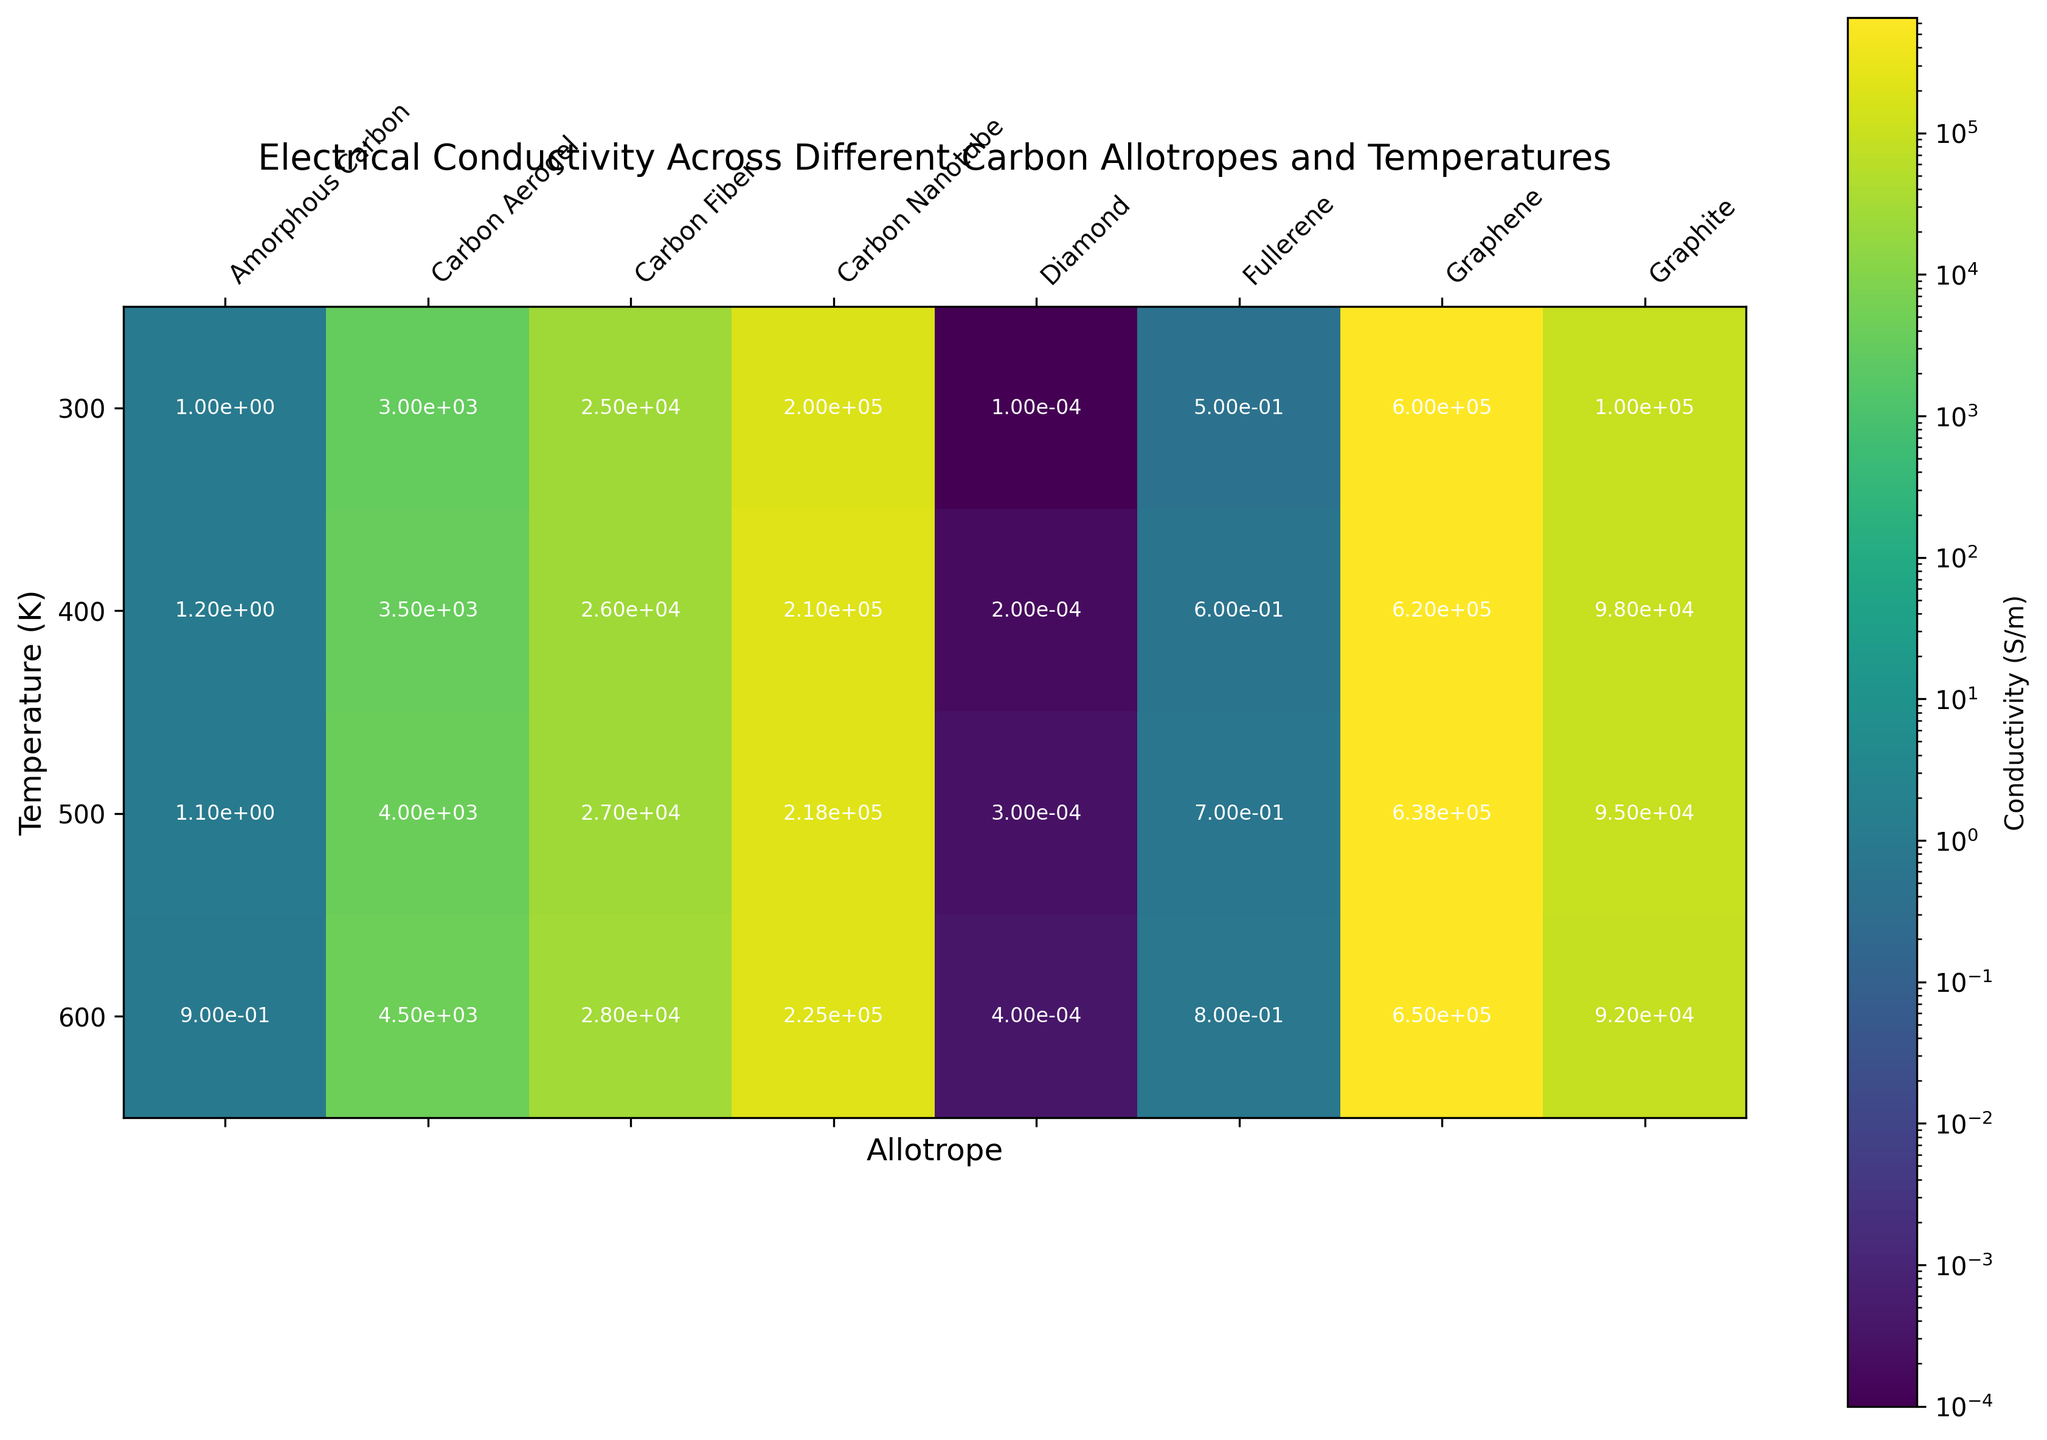Which carbon allotrope has the highest conductivity at 300 K? By observing the top row (300 K) of the heatmap, we need to identify the cell with the brightest color, indicating the highest conductivity. Graphene stands out with the brightest color and highest conductivity value.
Answer: Graphene How does the conductivity of carbon nanotube change from 300 K to 600 K? Locate the row corresponding to carbon nanotube in the heatmap. Note the conductivity values: 200,000 S/m at 300 K and 225,000 S/m at 600 K. Calculate the difference: 225,000 - 200,000 = 25,000 S/m. Thus, conductivity increases by 25,000 S/m.
Answer: Increases by 25,000 S/m Which allotrope shows the least change in conductivity across the temperature range? Examine the color variations for each column from 300 K to 600 K. The column with the least noticeable change is for amorphous carbon, showing stable or minimal changes in color shades.
Answer: Amorphous Carbon What is the ratio of graphene's conductivity to graphite's conductivity at 500 K? Find the conductivities for both materials at 500 K: Graphene is 638,000 S/m, and Graphite is 95,000 S/m. Calculate the ratio: 638,000 / 95,000 ≈ 6.72.
Answer: 6.72 Which allotrope's conductivity increases most significantly as the temperature rises from 300 K to 600 K? Identify the rows which show the most significant changes in color intensity (brightness) among all allotropes from 300 K to 600 K. Graphene's color intensity rises sharply, indicating the highest increase in conductivity.
Answer: Graphene Compare the conductivities of carbon fiber and carbon aerogel at 400 K. Which one is greater and by how much? Locate the values for both at 400 K: Carbon Fiber is 26,000 S/m, and Carbon Aerogel is 3,500 S/m. Calculate the difference: 26,000 - 3,500 = 22,500 S/m. Thus, carbon fiber has greater conductivity by 22,500 S/m.
Answer: Carbon Fiber by 22,500 S/m At which temperature does diamond's conductivity equal fullerene's conductivity? By examining diamond and fullerene columns, identify the temperature at which their colors are the same. Both have similar colors at 600 K, with respective conductivity values close to 0.0004 S/m and 0.8 S/m, which makes this a trick question as levels are visibly different.
Answer: None What’s the average conductivity of graphene across all temperatures in the dataset? Sum graphene's conductivity values across all temperatures: 600,000 + 620,000 + 638,000 + 650,000 = 2,508,000. Divide by the number of values: 2,508,000 / 4 = 627,000 S/m.
Answer: 627,000 S/m By what factor does graphite's conductivity decrease from 300 K to 600 K? Note graphite's values at these temperatures: 100,000 at 300 K and 92,000 at 600 K. The factor is calculated as 100,000 / 92,000 ≈ 1.087.
Answer: 1.087 